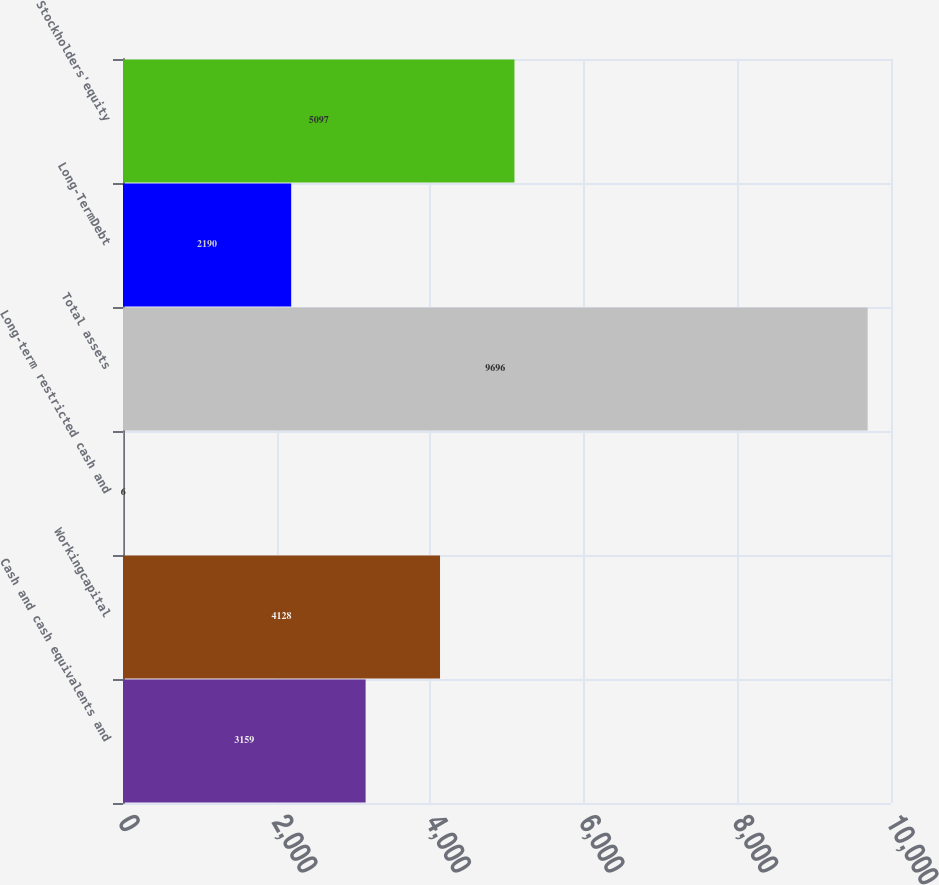<chart> <loc_0><loc_0><loc_500><loc_500><bar_chart><fcel>Cash and cash equivalents and<fcel>Workingcapital<fcel>Long-term restricted cash and<fcel>Total assets<fcel>Long-TermDebt<fcel>Stockholders'equity<nl><fcel>3159<fcel>4128<fcel>6<fcel>9696<fcel>2190<fcel>5097<nl></chart> 